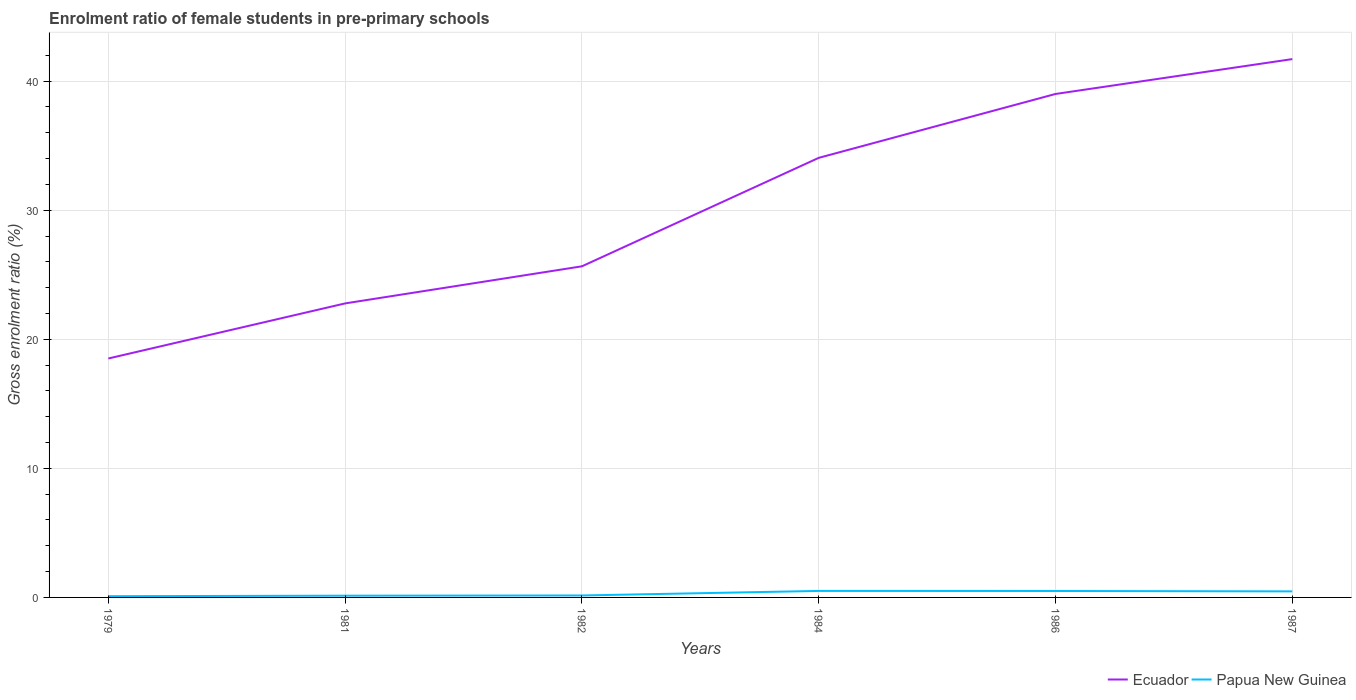How many different coloured lines are there?
Provide a succinct answer. 2. Does the line corresponding to Ecuador intersect with the line corresponding to Papua New Guinea?
Offer a very short reply. No. Across all years, what is the maximum enrolment ratio of female students in pre-primary schools in Papua New Guinea?
Ensure brevity in your answer.  0.1. In which year was the enrolment ratio of female students in pre-primary schools in Ecuador maximum?
Offer a very short reply. 1979. What is the total enrolment ratio of female students in pre-primary schools in Ecuador in the graph?
Your response must be concise. -20.49. What is the difference between the highest and the second highest enrolment ratio of female students in pre-primary schools in Ecuador?
Your response must be concise. 23.2. What is the difference between the highest and the lowest enrolment ratio of female students in pre-primary schools in Papua New Guinea?
Offer a terse response. 3. What is the difference between two consecutive major ticks on the Y-axis?
Keep it short and to the point. 10. Does the graph contain any zero values?
Keep it short and to the point. No. Does the graph contain grids?
Your answer should be compact. Yes. How are the legend labels stacked?
Ensure brevity in your answer.  Horizontal. What is the title of the graph?
Provide a succinct answer. Enrolment ratio of female students in pre-primary schools. Does "Qatar" appear as one of the legend labels in the graph?
Provide a succinct answer. No. What is the label or title of the X-axis?
Your answer should be compact. Years. What is the Gross enrolment ratio (%) in Ecuador in 1979?
Your response must be concise. 18.51. What is the Gross enrolment ratio (%) of Papua New Guinea in 1979?
Keep it short and to the point. 0.1. What is the Gross enrolment ratio (%) of Ecuador in 1981?
Your answer should be very brief. 22.78. What is the Gross enrolment ratio (%) in Papua New Guinea in 1981?
Your answer should be compact. 0.14. What is the Gross enrolment ratio (%) of Ecuador in 1982?
Your answer should be very brief. 25.65. What is the Gross enrolment ratio (%) of Papua New Guinea in 1982?
Offer a terse response. 0.15. What is the Gross enrolment ratio (%) of Ecuador in 1984?
Your answer should be compact. 34.06. What is the Gross enrolment ratio (%) of Papua New Guinea in 1984?
Keep it short and to the point. 0.5. What is the Gross enrolment ratio (%) in Ecuador in 1986?
Make the answer very short. 39.01. What is the Gross enrolment ratio (%) in Papua New Guinea in 1986?
Ensure brevity in your answer.  0.5. What is the Gross enrolment ratio (%) of Ecuador in 1987?
Provide a short and direct response. 41.71. What is the Gross enrolment ratio (%) in Papua New Guinea in 1987?
Your answer should be very brief. 0.47. Across all years, what is the maximum Gross enrolment ratio (%) of Ecuador?
Offer a terse response. 41.71. Across all years, what is the maximum Gross enrolment ratio (%) in Papua New Guinea?
Ensure brevity in your answer.  0.5. Across all years, what is the minimum Gross enrolment ratio (%) of Ecuador?
Keep it short and to the point. 18.51. Across all years, what is the minimum Gross enrolment ratio (%) of Papua New Guinea?
Your answer should be compact. 0.1. What is the total Gross enrolment ratio (%) in Ecuador in the graph?
Provide a short and direct response. 181.72. What is the total Gross enrolment ratio (%) in Papua New Guinea in the graph?
Your answer should be very brief. 1.85. What is the difference between the Gross enrolment ratio (%) in Ecuador in 1979 and that in 1981?
Ensure brevity in your answer.  -4.27. What is the difference between the Gross enrolment ratio (%) in Papua New Guinea in 1979 and that in 1981?
Your response must be concise. -0.04. What is the difference between the Gross enrolment ratio (%) in Ecuador in 1979 and that in 1982?
Your answer should be very brief. -7.14. What is the difference between the Gross enrolment ratio (%) in Papua New Guinea in 1979 and that in 1982?
Your answer should be very brief. -0.06. What is the difference between the Gross enrolment ratio (%) in Ecuador in 1979 and that in 1984?
Your answer should be very brief. -15.54. What is the difference between the Gross enrolment ratio (%) of Papua New Guinea in 1979 and that in 1984?
Your answer should be very brief. -0.41. What is the difference between the Gross enrolment ratio (%) of Ecuador in 1979 and that in 1986?
Make the answer very short. -20.49. What is the difference between the Gross enrolment ratio (%) in Papua New Guinea in 1979 and that in 1986?
Ensure brevity in your answer.  -0.4. What is the difference between the Gross enrolment ratio (%) in Ecuador in 1979 and that in 1987?
Keep it short and to the point. -23.2. What is the difference between the Gross enrolment ratio (%) in Papua New Guinea in 1979 and that in 1987?
Your answer should be very brief. -0.37. What is the difference between the Gross enrolment ratio (%) in Ecuador in 1981 and that in 1982?
Keep it short and to the point. -2.87. What is the difference between the Gross enrolment ratio (%) in Papua New Guinea in 1981 and that in 1982?
Provide a succinct answer. -0.02. What is the difference between the Gross enrolment ratio (%) of Ecuador in 1981 and that in 1984?
Your answer should be compact. -11.28. What is the difference between the Gross enrolment ratio (%) of Papua New Guinea in 1981 and that in 1984?
Give a very brief answer. -0.37. What is the difference between the Gross enrolment ratio (%) in Ecuador in 1981 and that in 1986?
Offer a very short reply. -16.23. What is the difference between the Gross enrolment ratio (%) of Papua New Guinea in 1981 and that in 1986?
Your answer should be compact. -0.36. What is the difference between the Gross enrolment ratio (%) in Ecuador in 1981 and that in 1987?
Provide a succinct answer. -18.93. What is the difference between the Gross enrolment ratio (%) of Papua New Guinea in 1981 and that in 1987?
Offer a very short reply. -0.33. What is the difference between the Gross enrolment ratio (%) of Ecuador in 1982 and that in 1984?
Keep it short and to the point. -8.4. What is the difference between the Gross enrolment ratio (%) of Papua New Guinea in 1982 and that in 1984?
Offer a terse response. -0.35. What is the difference between the Gross enrolment ratio (%) of Ecuador in 1982 and that in 1986?
Your answer should be compact. -13.35. What is the difference between the Gross enrolment ratio (%) of Papua New Guinea in 1982 and that in 1986?
Keep it short and to the point. -0.35. What is the difference between the Gross enrolment ratio (%) in Ecuador in 1982 and that in 1987?
Make the answer very short. -16.05. What is the difference between the Gross enrolment ratio (%) of Papua New Guinea in 1982 and that in 1987?
Offer a very short reply. -0.32. What is the difference between the Gross enrolment ratio (%) of Ecuador in 1984 and that in 1986?
Make the answer very short. -4.95. What is the difference between the Gross enrolment ratio (%) in Papua New Guinea in 1984 and that in 1986?
Keep it short and to the point. 0. What is the difference between the Gross enrolment ratio (%) in Ecuador in 1984 and that in 1987?
Your response must be concise. -7.65. What is the difference between the Gross enrolment ratio (%) of Papua New Guinea in 1984 and that in 1987?
Keep it short and to the point. 0.03. What is the difference between the Gross enrolment ratio (%) in Ecuador in 1986 and that in 1987?
Offer a very short reply. -2.7. What is the difference between the Gross enrolment ratio (%) of Papua New Guinea in 1986 and that in 1987?
Your answer should be compact. 0.03. What is the difference between the Gross enrolment ratio (%) in Ecuador in 1979 and the Gross enrolment ratio (%) in Papua New Guinea in 1981?
Ensure brevity in your answer.  18.38. What is the difference between the Gross enrolment ratio (%) of Ecuador in 1979 and the Gross enrolment ratio (%) of Papua New Guinea in 1982?
Your response must be concise. 18.36. What is the difference between the Gross enrolment ratio (%) in Ecuador in 1979 and the Gross enrolment ratio (%) in Papua New Guinea in 1984?
Keep it short and to the point. 18.01. What is the difference between the Gross enrolment ratio (%) of Ecuador in 1979 and the Gross enrolment ratio (%) of Papua New Guinea in 1986?
Provide a short and direct response. 18.01. What is the difference between the Gross enrolment ratio (%) in Ecuador in 1979 and the Gross enrolment ratio (%) in Papua New Guinea in 1987?
Give a very brief answer. 18.04. What is the difference between the Gross enrolment ratio (%) in Ecuador in 1981 and the Gross enrolment ratio (%) in Papua New Guinea in 1982?
Provide a succinct answer. 22.63. What is the difference between the Gross enrolment ratio (%) in Ecuador in 1981 and the Gross enrolment ratio (%) in Papua New Guinea in 1984?
Offer a very short reply. 22.28. What is the difference between the Gross enrolment ratio (%) of Ecuador in 1981 and the Gross enrolment ratio (%) of Papua New Guinea in 1986?
Your response must be concise. 22.28. What is the difference between the Gross enrolment ratio (%) of Ecuador in 1981 and the Gross enrolment ratio (%) of Papua New Guinea in 1987?
Keep it short and to the point. 22.31. What is the difference between the Gross enrolment ratio (%) in Ecuador in 1982 and the Gross enrolment ratio (%) in Papua New Guinea in 1984?
Keep it short and to the point. 25.15. What is the difference between the Gross enrolment ratio (%) of Ecuador in 1982 and the Gross enrolment ratio (%) of Papua New Guinea in 1986?
Give a very brief answer. 25.15. What is the difference between the Gross enrolment ratio (%) in Ecuador in 1982 and the Gross enrolment ratio (%) in Papua New Guinea in 1987?
Your response must be concise. 25.18. What is the difference between the Gross enrolment ratio (%) in Ecuador in 1984 and the Gross enrolment ratio (%) in Papua New Guinea in 1986?
Keep it short and to the point. 33.56. What is the difference between the Gross enrolment ratio (%) of Ecuador in 1984 and the Gross enrolment ratio (%) of Papua New Guinea in 1987?
Your answer should be very brief. 33.59. What is the difference between the Gross enrolment ratio (%) in Ecuador in 1986 and the Gross enrolment ratio (%) in Papua New Guinea in 1987?
Make the answer very short. 38.54. What is the average Gross enrolment ratio (%) in Ecuador per year?
Keep it short and to the point. 30.29. What is the average Gross enrolment ratio (%) in Papua New Guinea per year?
Your response must be concise. 0.31. In the year 1979, what is the difference between the Gross enrolment ratio (%) of Ecuador and Gross enrolment ratio (%) of Papua New Guinea?
Your answer should be compact. 18.42. In the year 1981, what is the difference between the Gross enrolment ratio (%) of Ecuador and Gross enrolment ratio (%) of Papua New Guinea?
Provide a succinct answer. 22.64. In the year 1982, what is the difference between the Gross enrolment ratio (%) of Ecuador and Gross enrolment ratio (%) of Papua New Guinea?
Offer a very short reply. 25.5. In the year 1984, what is the difference between the Gross enrolment ratio (%) of Ecuador and Gross enrolment ratio (%) of Papua New Guinea?
Your response must be concise. 33.55. In the year 1986, what is the difference between the Gross enrolment ratio (%) in Ecuador and Gross enrolment ratio (%) in Papua New Guinea?
Ensure brevity in your answer.  38.51. In the year 1987, what is the difference between the Gross enrolment ratio (%) of Ecuador and Gross enrolment ratio (%) of Papua New Guinea?
Offer a very short reply. 41.24. What is the ratio of the Gross enrolment ratio (%) of Ecuador in 1979 to that in 1981?
Make the answer very short. 0.81. What is the ratio of the Gross enrolment ratio (%) in Papua New Guinea in 1979 to that in 1981?
Give a very brief answer. 0.71. What is the ratio of the Gross enrolment ratio (%) in Ecuador in 1979 to that in 1982?
Give a very brief answer. 0.72. What is the ratio of the Gross enrolment ratio (%) in Papua New Guinea in 1979 to that in 1982?
Provide a short and direct response. 0.63. What is the ratio of the Gross enrolment ratio (%) of Ecuador in 1979 to that in 1984?
Your answer should be very brief. 0.54. What is the ratio of the Gross enrolment ratio (%) of Papua New Guinea in 1979 to that in 1984?
Your answer should be compact. 0.19. What is the ratio of the Gross enrolment ratio (%) in Ecuador in 1979 to that in 1986?
Offer a very short reply. 0.47. What is the ratio of the Gross enrolment ratio (%) in Papua New Guinea in 1979 to that in 1986?
Keep it short and to the point. 0.19. What is the ratio of the Gross enrolment ratio (%) in Ecuador in 1979 to that in 1987?
Provide a short and direct response. 0.44. What is the ratio of the Gross enrolment ratio (%) in Papua New Guinea in 1979 to that in 1987?
Your answer should be compact. 0.2. What is the ratio of the Gross enrolment ratio (%) of Ecuador in 1981 to that in 1982?
Offer a very short reply. 0.89. What is the ratio of the Gross enrolment ratio (%) of Papua New Guinea in 1981 to that in 1982?
Provide a short and direct response. 0.89. What is the ratio of the Gross enrolment ratio (%) of Ecuador in 1981 to that in 1984?
Your answer should be very brief. 0.67. What is the ratio of the Gross enrolment ratio (%) of Papua New Guinea in 1981 to that in 1984?
Keep it short and to the point. 0.27. What is the ratio of the Gross enrolment ratio (%) of Ecuador in 1981 to that in 1986?
Ensure brevity in your answer.  0.58. What is the ratio of the Gross enrolment ratio (%) of Papua New Guinea in 1981 to that in 1986?
Offer a very short reply. 0.27. What is the ratio of the Gross enrolment ratio (%) of Ecuador in 1981 to that in 1987?
Offer a terse response. 0.55. What is the ratio of the Gross enrolment ratio (%) of Papua New Guinea in 1981 to that in 1987?
Give a very brief answer. 0.29. What is the ratio of the Gross enrolment ratio (%) in Ecuador in 1982 to that in 1984?
Offer a terse response. 0.75. What is the ratio of the Gross enrolment ratio (%) in Papua New Guinea in 1982 to that in 1984?
Make the answer very short. 0.3. What is the ratio of the Gross enrolment ratio (%) in Ecuador in 1982 to that in 1986?
Provide a succinct answer. 0.66. What is the ratio of the Gross enrolment ratio (%) in Papua New Guinea in 1982 to that in 1986?
Your answer should be very brief. 0.3. What is the ratio of the Gross enrolment ratio (%) of Ecuador in 1982 to that in 1987?
Provide a short and direct response. 0.62. What is the ratio of the Gross enrolment ratio (%) in Papua New Guinea in 1982 to that in 1987?
Offer a terse response. 0.32. What is the ratio of the Gross enrolment ratio (%) in Ecuador in 1984 to that in 1986?
Keep it short and to the point. 0.87. What is the ratio of the Gross enrolment ratio (%) in Papua New Guinea in 1984 to that in 1986?
Give a very brief answer. 1.01. What is the ratio of the Gross enrolment ratio (%) of Ecuador in 1984 to that in 1987?
Offer a terse response. 0.82. What is the ratio of the Gross enrolment ratio (%) in Papua New Guinea in 1984 to that in 1987?
Keep it short and to the point. 1.07. What is the ratio of the Gross enrolment ratio (%) of Ecuador in 1986 to that in 1987?
Your answer should be compact. 0.94. What is the ratio of the Gross enrolment ratio (%) of Papua New Guinea in 1986 to that in 1987?
Give a very brief answer. 1.07. What is the difference between the highest and the second highest Gross enrolment ratio (%) of Ecuador?
Offer a very short reply. 2.7. What is the difference between the highest and the second highest Gross enrolment ratio (%) of Papua New Guinea?
Make the answer very short. 0. What is the difference between the highest and the lowest Gross enrolment ratio (%) in Ecuador?
Offer a terse response. 23.2. What is the difference between the highest and the lowest Gross enrolment ratio (%) in Papua New Guinea?
Provide a short and direct response. 0.41. 